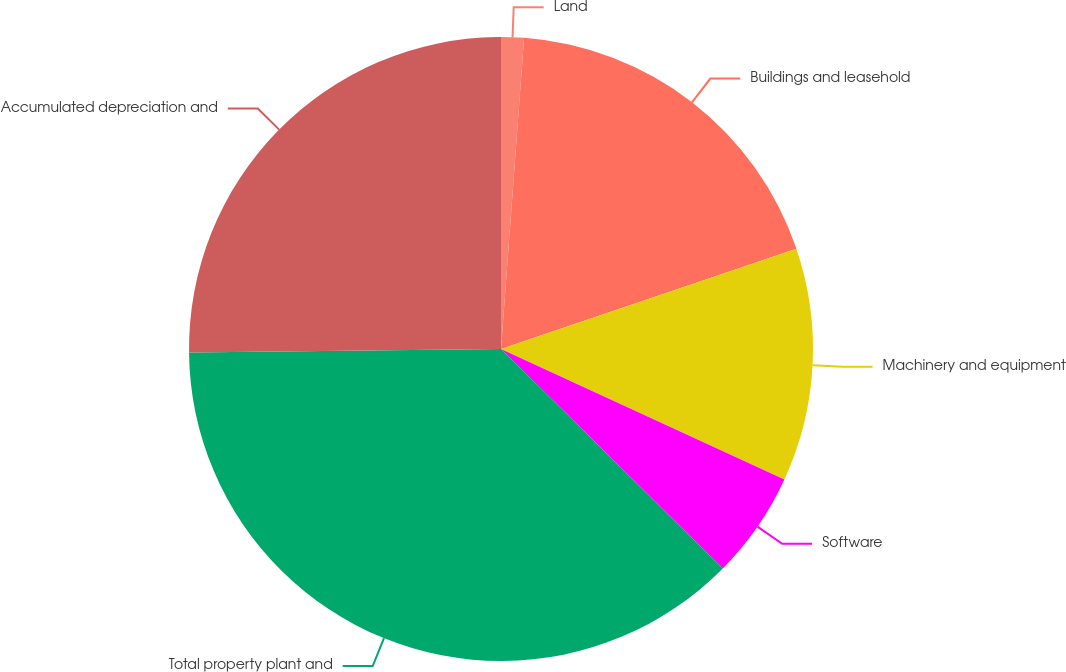Convert chart to OTSL. <chart><loc_0><loc_0><loc_500><loc_500><pie_chart><fcel>Land<fcel>Buildings and leasehold<fcel>Machinery and equipment<fcel>Software<fcel>Total property plant and<fcel>Accumulated depreciation and<nl><fcel>1.18%<fcel>18.61%<fcel>12.08%<fcel>5.55%<fcel>37.41%<fcel>25.18%<nl></chart> 